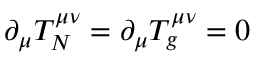Convert formula to latex. <formula><loc_0><loc_0><loc_500><loc_500>\partial _ { \mu } T _ { N } ^ { \mu \nu } = \partial _ { \mu } T _ { g } ^ { \mu \nu } = 0</formula> 